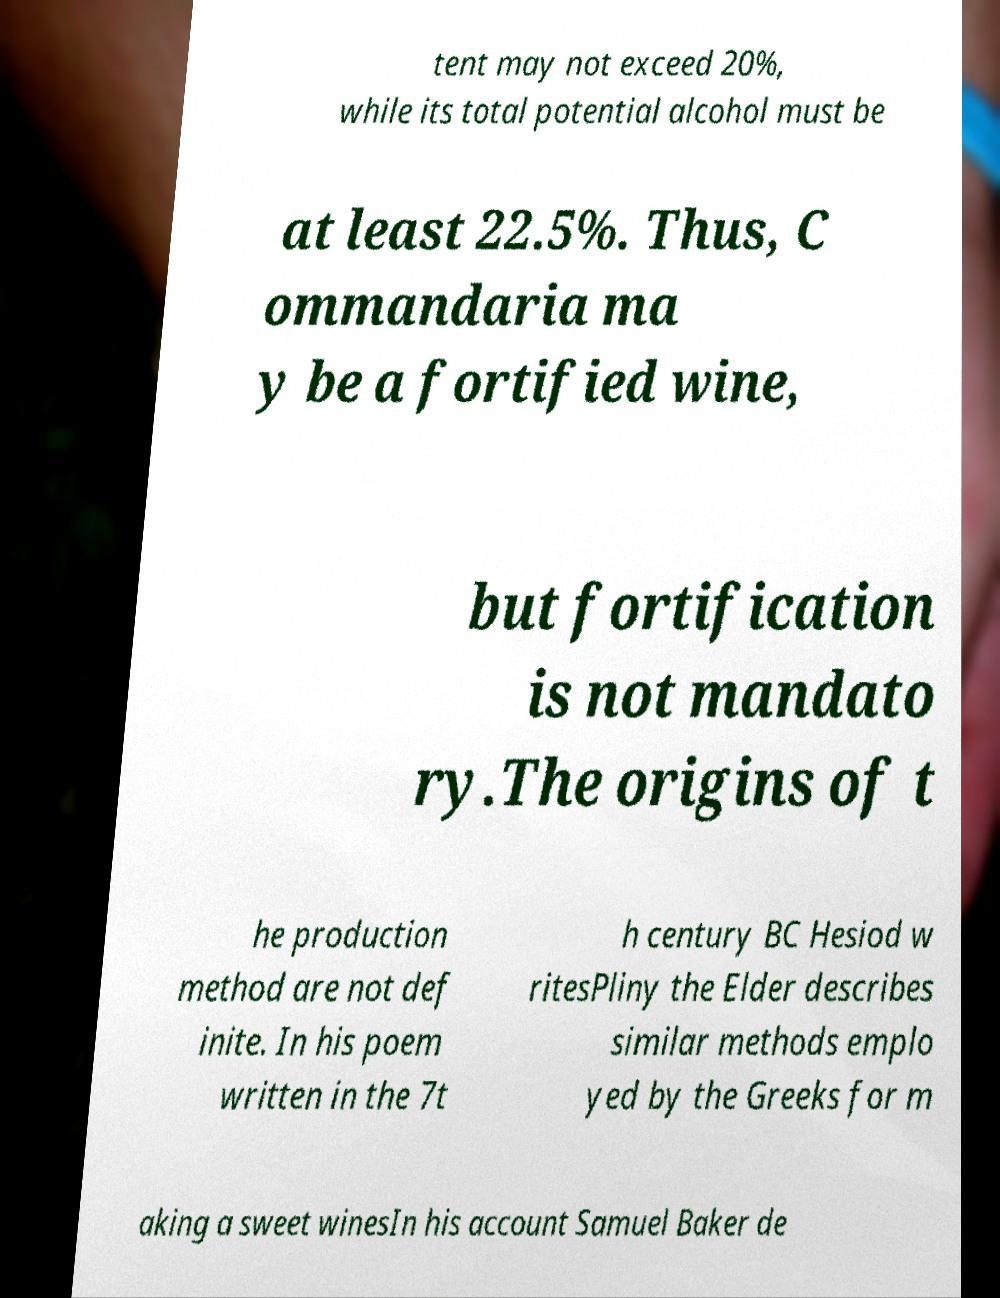Can you read and provide the text displayed in the image?This photo seems to have some interesting text. Can you extract and type it out for me? tent may not exceed 20%, while its total potential alcohol must be at least 22.5%. Thus, C ommandaria ma y be a fortified wine, but fortification is not mandato ry.The origins of t he production method are not def inite. In his poem written in the 7t h century BC Hesiod w ritesPliny the Elder describes similar methods emplo yed by the Greeks for m aking a sweet winesIn his account Samuel Baker de 